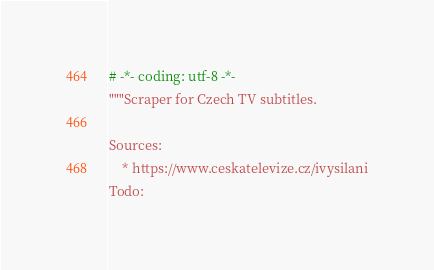<code> <loc_0><loc_0><loc_500><loc_500><_Python_># -*- coding: utf-8 -*-
"""Scraper for Czech TV subtitles.
 
Sources:
    * https://www.ceskatelevize.cz/ivysilani
Todo:</code> 